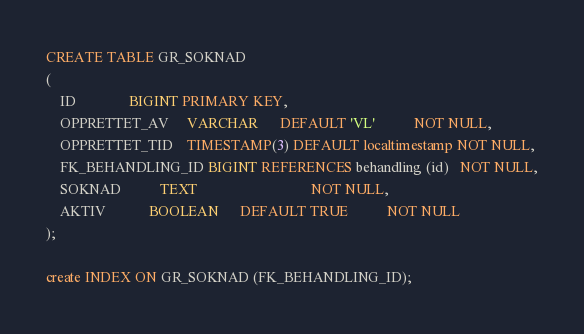Convert code to text. <code><loc_0><loc_0><loc_500><loc_500><_SQL_>CREATE TABLE GR_SOKNAD
(
    ID               BIGINT PRIMARY KEY,
    OPPRETTET_AV     VARCHAR      DEFAULT 'VL'           NOT NULL,
    OPPRETTET_TID    TIMESTAMP(3) DEFAULT localtimestamp NOT NULL,
    FK_BEHANDLING_ID BIGINT REFERENCES behandling (id)   NOT NULL,
    SOKNAD           TEXT                                NOT NULL,
    AKTIV            BOOLEAN      DEFAULT TRUE           NOT NULL
);

create INDEX ON GR_SOKNAD (FK_BEHANDLING_ID);</code> 